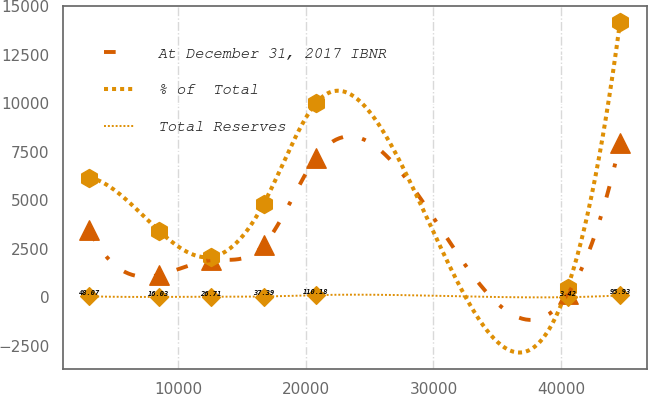<chart> <loc_0><loc_0><loc_500><loc_500><line_chart><ecel><fcel>At December 31, 2017 IBNR<fcel>% of  Total<fcel>Total Reserves<nl><fcel>3058.61<fcel>3450.98<fcel>6175.96<fcel>48.07<nl><fcel>8483.27<fcel>1142.66<fcel>3440.62<fcel>16.03<nl><fcel>12588.6<fcel>1912.1<fcel>2072.95<fcel>26.71<nl><fcel>16694<fcel>2681.54<fcel>4808.29<fcel>37.39<nl><fcel>20799.4<fcel>7190.62<fcel>10012<fcel>110.18<nl><fcel>40506.3<fcel>152.59<fcel>501.85<fcel>3.42<nl><fcel>44611.7<fcel>7960.06<fcel>14178.5<fcel>95.93<nl></chart> 